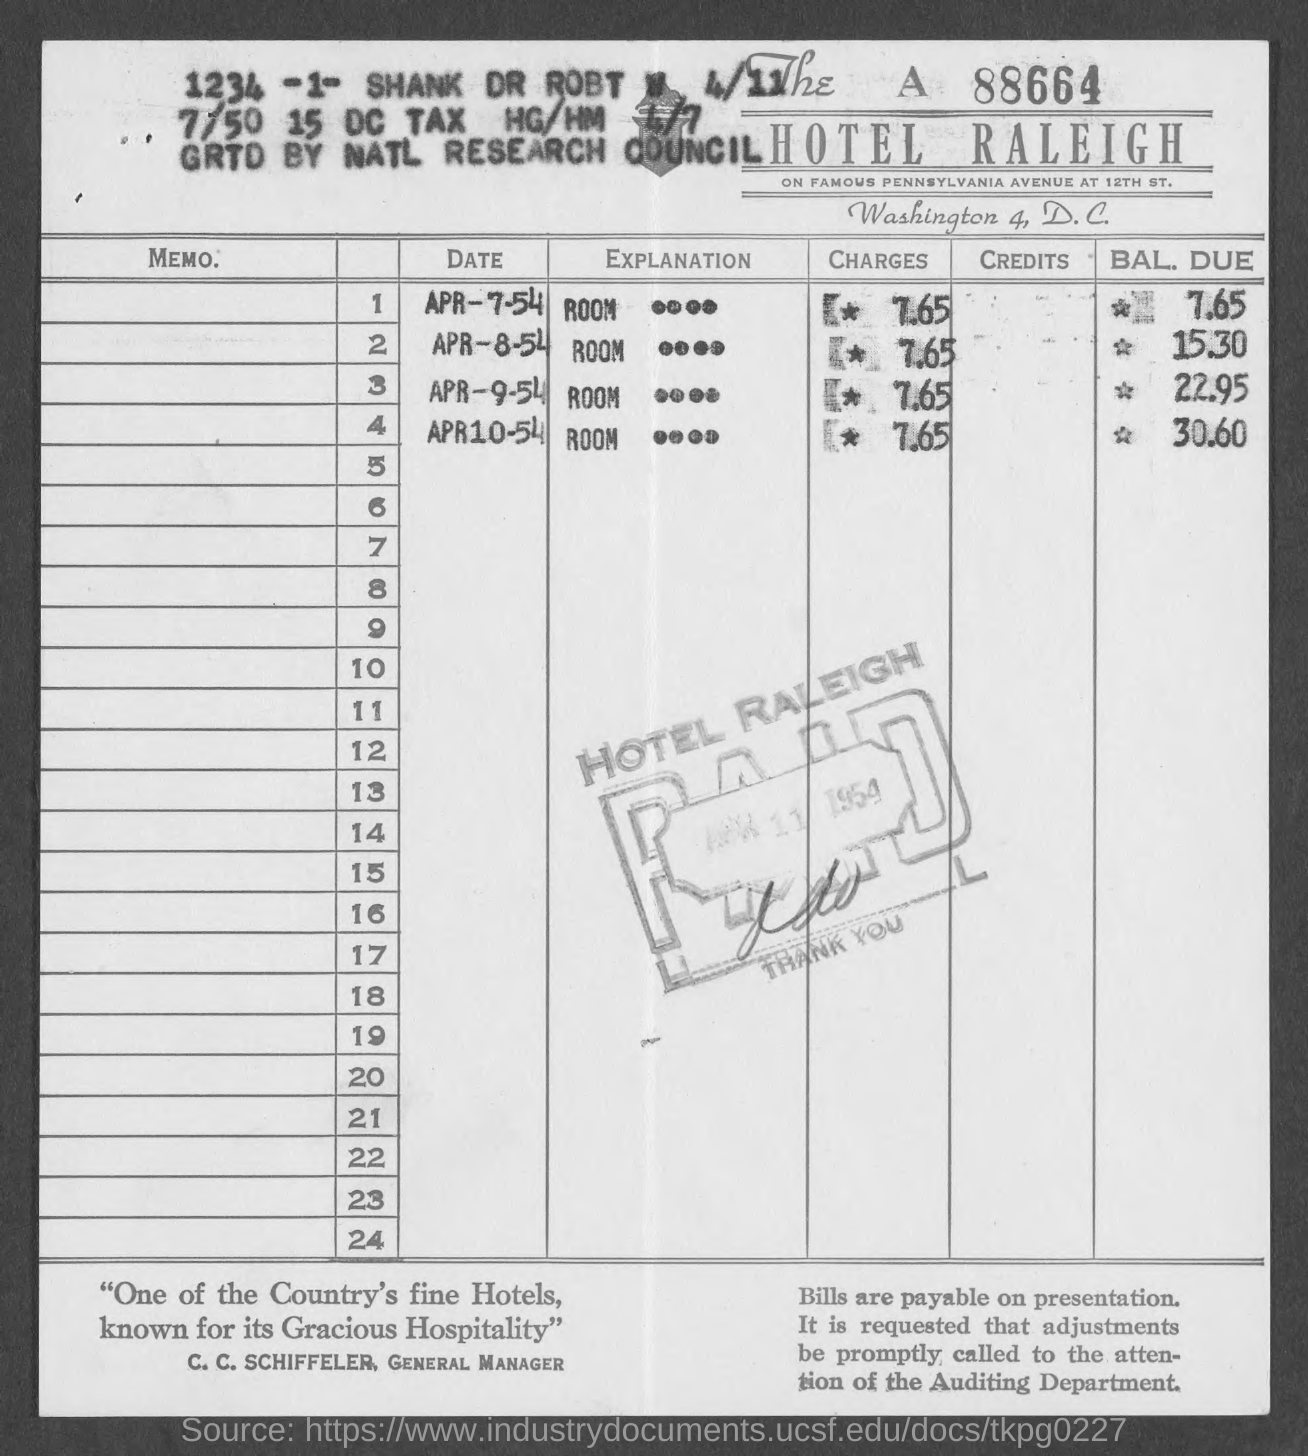What is the bill number mentioned at right top corner of the bill?
Provide a short and direct response. A 88664. What is the name of the hotel?
Ensure brevity in your answer.  Hotel raleigh. Which street on "PENNSYLVANIA AVENUE" is "HOTEL RALEIGH" located?
Provide a succinct answer. 12th st. Mention the CHARGES for ROOM booked on APR-7-54?
Your response must be concise. 7 65. Mention the BAL. DUE for ROOM booked on APR-8-54?
Make the answer very short. 15.30. Mention the BAL. DUE for ROOM booked on APR-9-54?
Provide a short and direct response. 22 95. Mention the BAL. DUE for ROOM booked on APR10-54?
Provide a short and direct response. 30 60. What is the designation of "C. C. SCHIFFELER"?
Provide a short and direct response. GENERAL MANAGER. 